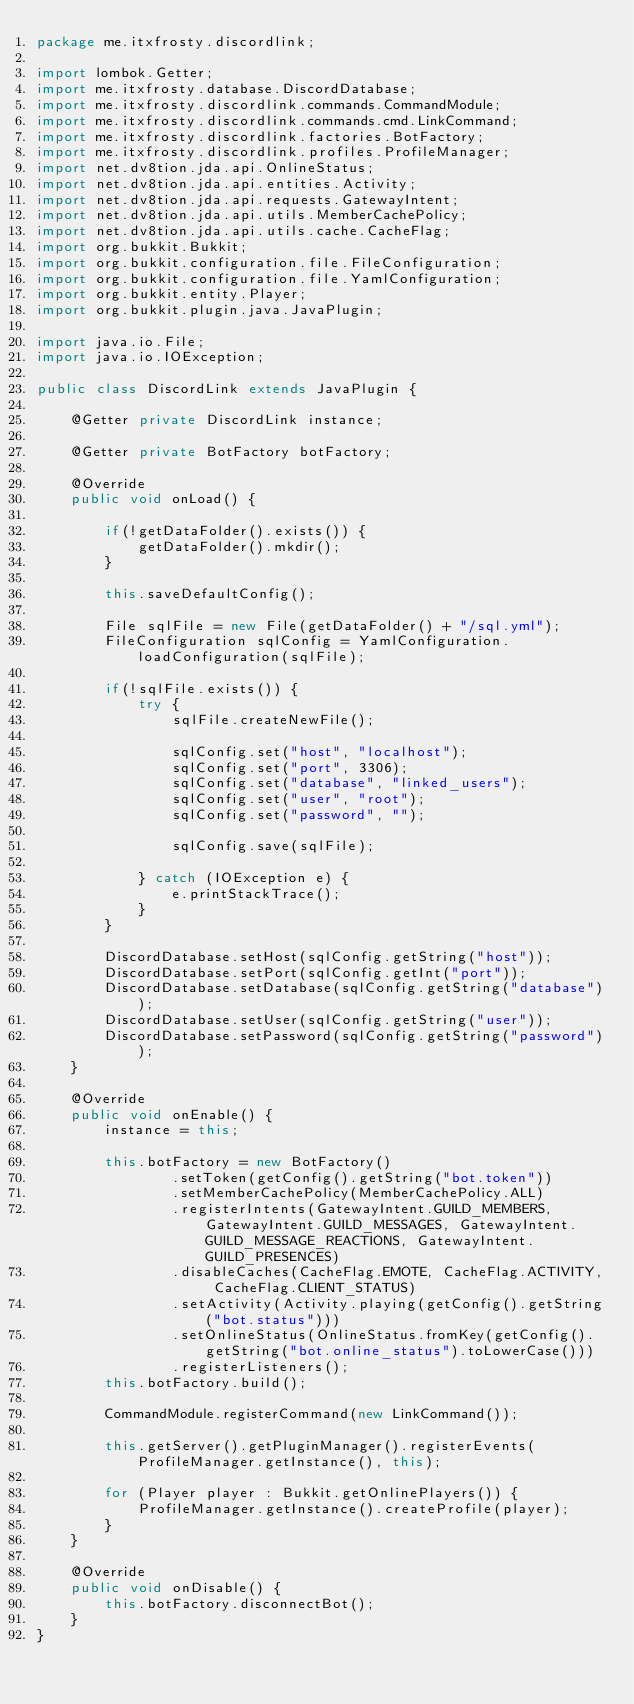Convert code to text. <code><loc_0><loc_0><loc_500><loc_500><_Java_>package me.itxfrosty.discordlink;

import lombok.Getter;
import me.itxfrosty.database.DiscordDatabase;
import me.itxfrosty.discordlink.commands.CommandModule;
import me.itxfrosty.discordlink.commands.cmd.LinkCommand;
import me.itxfrosty.discordlink.factories.BotFactory;
import me.itxfrosty.discordlink.profiles.ProfileManager;
import net.dv8tion.jda.api.OnlineStatus;
import net.dv8tion.jda.api.entities.Activity;
import net.dv8tion.jda.api.requests.GatewayIntent;
import net.dv8tion.jda.api.utils.MemberCachePolicy;
import net.dv8tion.jda.api.utils.cache.CacheFlag;
import org.bukkit.Bukkit;
import org.bukkit.configuration.file.FileConfiguration;
import org.bukkit.configuration.file.YamlConfiguration;
import org.bukkit.entity.Player;
import org.bukkit.plugin.java.JavaPlugin;

import java.io.File;
import java.io.IOException;

public class DiscordLink extends JavaPlugin {

	@Getter private DiscordLink instance;

	@Getter private BotFactory botFactory;

	@Override
	public void onLoad() {

		if(!getDataFolder().exists()) {
			getDataFolder().mkdir();
		}

		this.saveDefaultConfig();

		File sqlFile = new File(getDataFolder() + "/sql.yml");
		FileConfiguration sqlConfig = YamlConfiguration.loadConfiguration(sqlFile);

		if(!sqlFile.exists()) {
			try {
				sqlFile.createNewFile();

				sqlConfig.set("host", "localhost");
				sqlConfig.set("port", 3306);
				sqlConfig.set("database", "linked_users");
				sqlConfig.set("user", "root");
				sqlConfig.set("password", "");

				sqlConfig.save(sqlFile);

			} catch (IOException e) {
				e.printStackTrace();
			}
		}

		DiscordDatabase.setHost(sqlConfig.getString("host"));
		DiscordDatabase.setPort(sqlConfig.getInt("port"));
		DiscordDatabase.setDatabase(sqlConfig.getString("database"));
		DiscordDatabase.setUser(sqlConfig.getString("user"));
		DiscordDatabase.setPassword(sqlConfig.getString("password"));
	}

	@Override
	public void onEnable() {
		instance = this;

		this.botFactory = new BotFactory()
				.setToken(getConfig().getString("bot.token"))
				.setMemberCachePolicy(MemberCachePolicy.ALL)
				.registerIntents(GatewayIntent.GUILD_MEMBERS, GatewayIntent.GUILD_MESSAGES, GatewayIntent.GUILD_MESSAGE_REACTIONS, GatewayIntent.GUILD_PRESENCES)
				.disableCaches(CacheFlag.EMOTE, CacheFlag.ACTIVITY, CacheFlag.CLIENT_STATUS)
				.setActivity(Activity.playing(getConfig().getString("bot.status")))
				.setOnlineStatus(OnlineStatus.fromKey(getConfig().getString("bot.online_status").toLowerCase()))
				.registerListeners();
		this.botFactory.build();

		CommandModule.registerCommand(new LinkCommand());

		this.getServer().getPluginManager().registerEvents(ProfileManager.getInstance(), this);

		for (Player player : Bukkit.getOnlinePlayers()) {
			ProfileManager.getInstance().createProfile(player);
		}
	}

	@Override
	public void onDisable() {
		this.botFactory.disconnectBot();
	}
}
</code> 